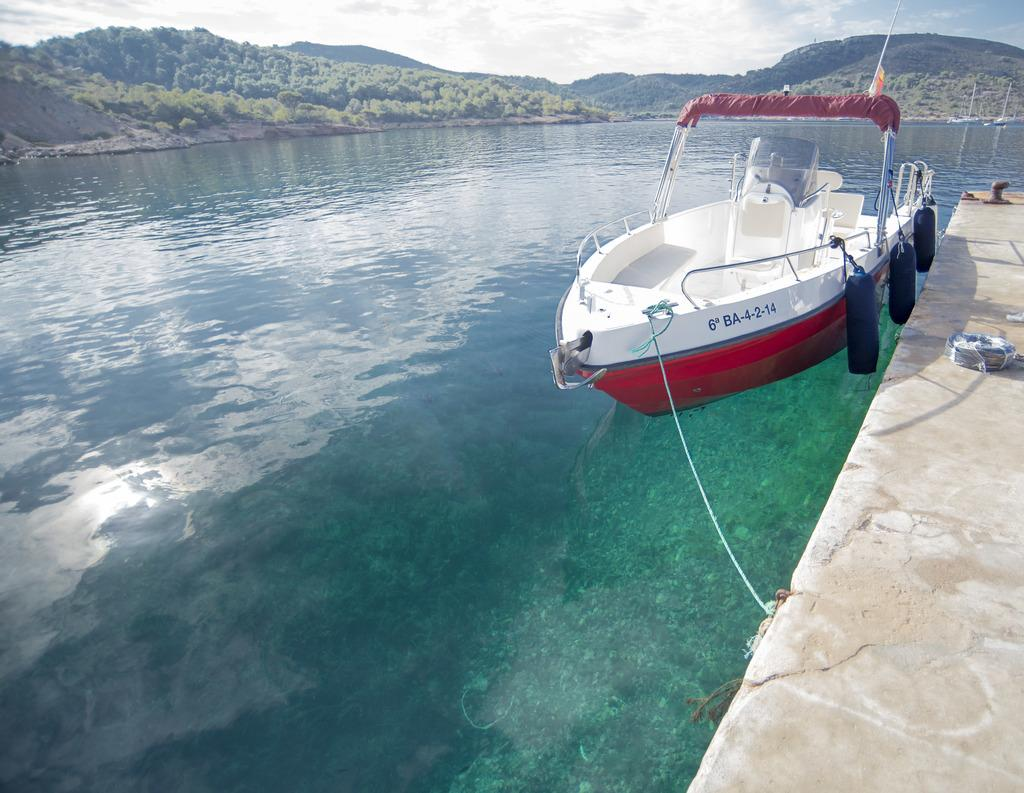What is the boat doing in the image? The boat is above the water in the image. What can be seen connecting the boat to another object? There is a rope visible in the image. Can you describe the object in the image? There is an object in the image, but its specific details are not mentioned in the facts. What can be seen in the background of the image? There are trees, hills, and the sky visible in the background of the image. What is the condition of the sky in the image? Clouds are present in the sky in the image. What type of wood is used to make the mask in the image? There is no mask present in the image; it features a boat above the water with a rope and an object, as well as trees, hills, and clouds in the sky. What committee is responsible for the maintenance of the hills in the image? There is no mention of a committee or any maintenance responsibility in the image. 